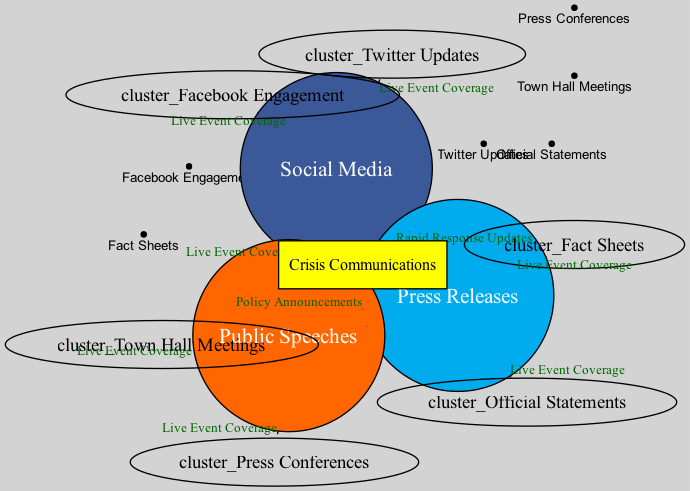What are the three messaging strategies shown in the diagram? The diagram shows three distinct sets representing different messaging strategies: "Social Media," "Press Releases," and "Public Speeches." These are directly labeled in the diagram.
Answer: Social Media, Press Releases, Public Speeches How many intersections are there between different messaging strategies? The diagram contains four intersections. One of the intersections includes all three strategies, while the others involve pairs of the three sets. This can be counted by observing the connecting edges for intersections.
Answer: 4 What is the unique label for the intersection of all three messaging strategies? The diagram specifies a unique label for the intersection of all three sets as "Crisis Communications." This label is prominently displayed within a box representing the shared area.
Answer: Crisis Communications Which platform is associated with "Official Statements"? The label "Official Statements" is listed under the "Press Releases" set in the diagram. This connection can be derived from reviewing the elements placed within each specific messaging strategy set.
Answer: Press Releases What type of content is shared between "Social Media" and "Press Releases"? The intersection of "Social Media" and "Press Releases" is labeled "Rapid Response Updates." This connection indicates the type of content that overlaps between these two strategies.
Answer: Rapid Response Updates How many specific types are listed under Social Media? There are two specific types listed under "Social Media" in the diagram: "Twitter Updates" and "Facebook Engagement." These can be counted by reviewing the labels contained in the "Social Media" set.
Answer: 2 What is the relationship depicted between "Public Speeches" and "Crisis Communications"? The diagram illustrates that "Public Speeches" shares a direct intersection with "Crisis Communications." This relationship is indicated by a dashed line connecting the "Public Speeches" set to the box labeled "Crisis Communications."
Answer: Shared Intersection Name one example of a messaging strategy associated with "Public Speeches." The diagram lists "Town Hall Meetings" and "Press Conferences" as examples under the "Public Speeches" strategy. Both can be identified in the corresponding set area.
Answer: Town Hall Meetings 